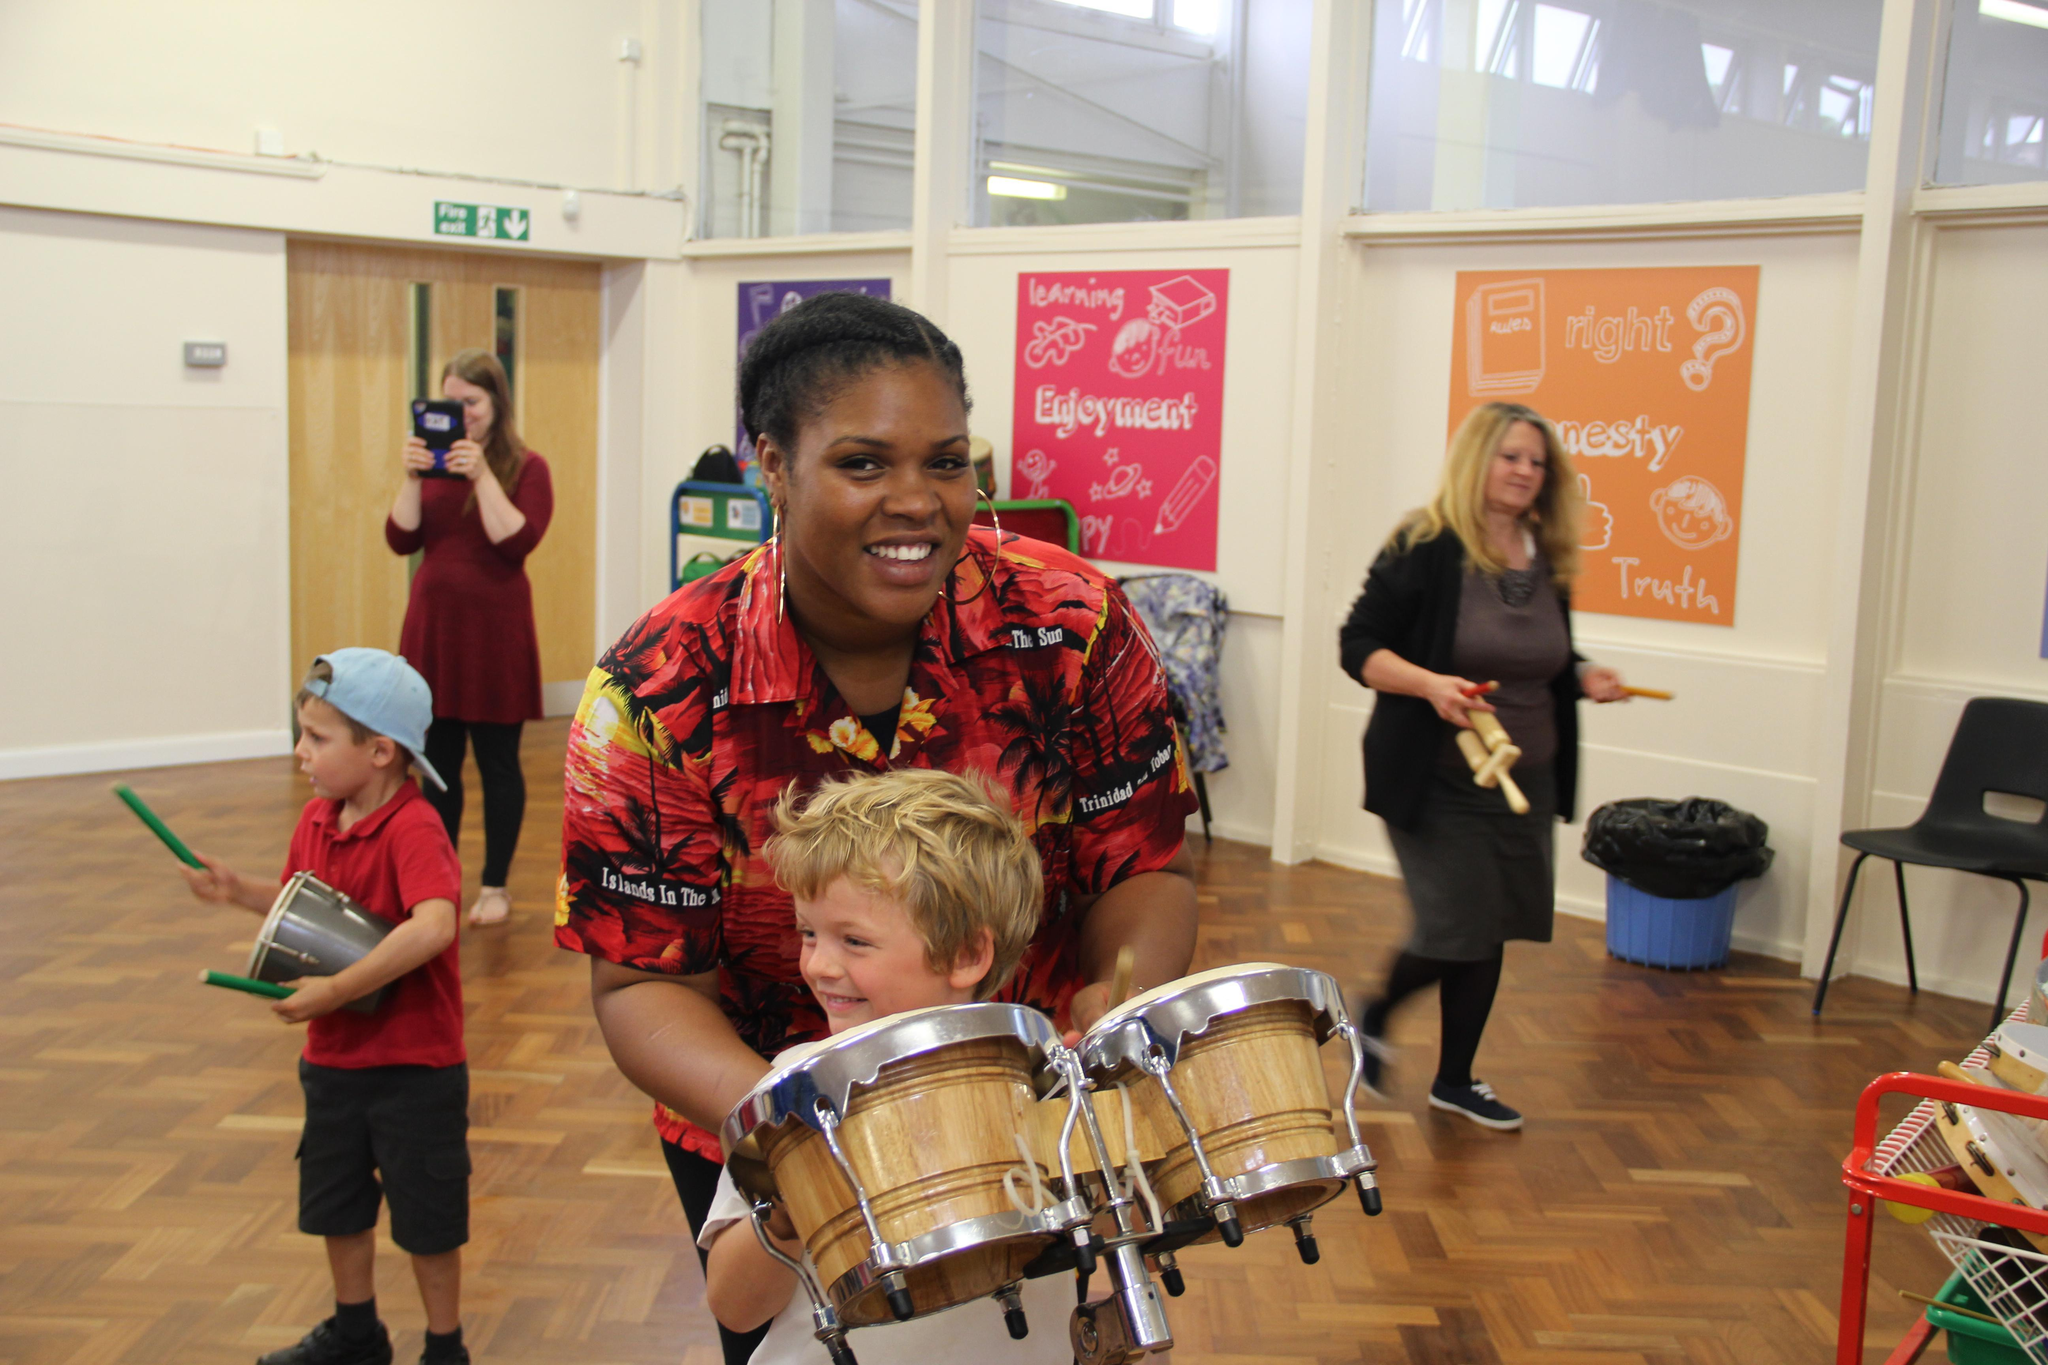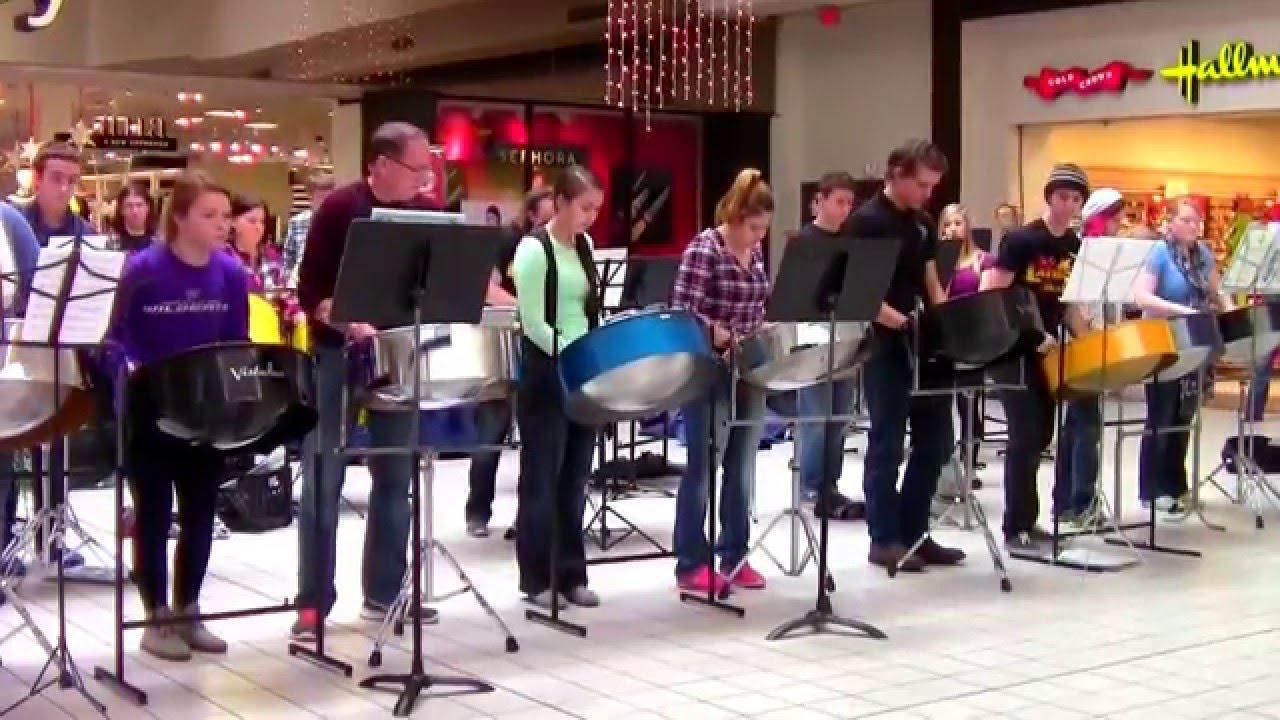The first image is the image on the left, the second image is the image on the right. Evaluate the accuracy of this statement regarding the images: "Someone is holding an instrument that is not related to drums.". Is it true? Answer yes or no. No. The first image is the image on the left, the second image is the image on the right. For the images displayed, is the sentence "In at least one image there are at least three women of color playing a fully metal drum." factually correct? Answer yes or no. No. 